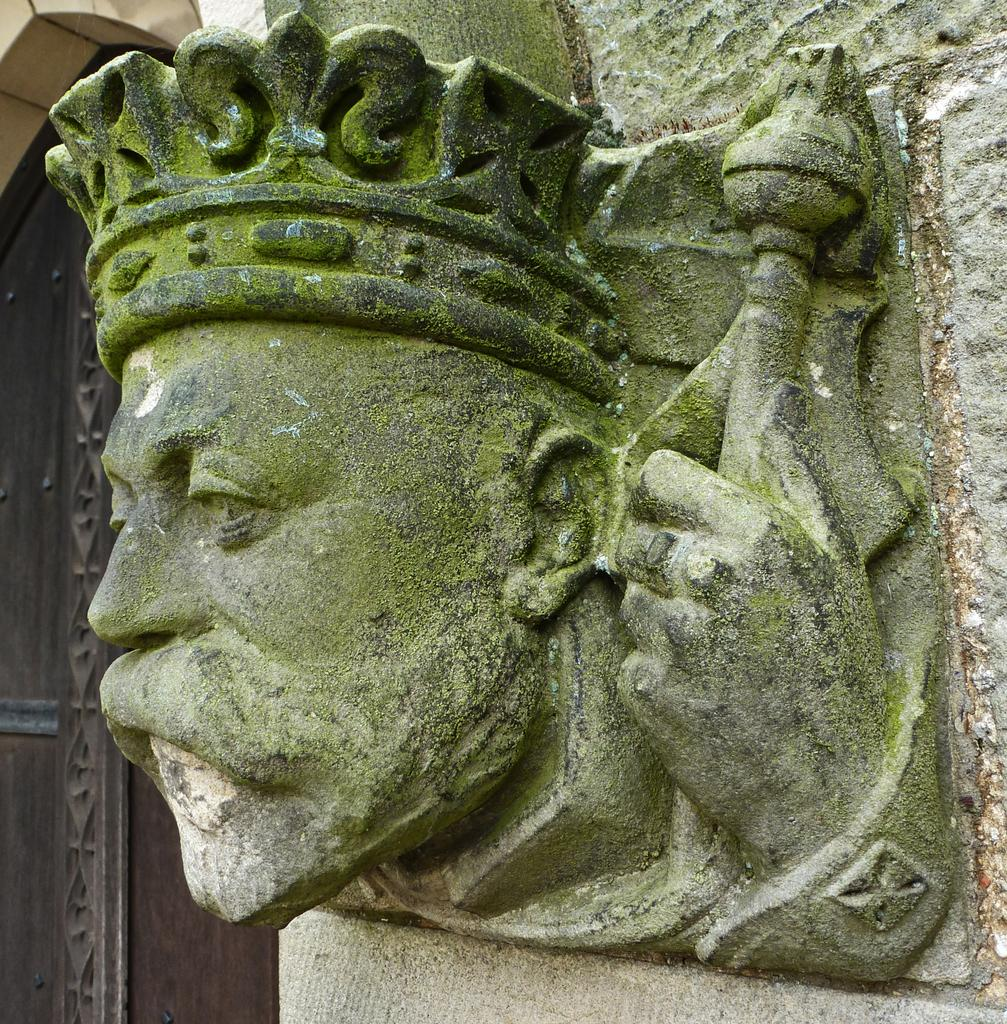What type of objects are on the wall in the image? There are statues on the wall in the image. What architectural feature is present in the image? There is a door in the image. What type of stone can be seen falling from the wall in the image? There is no stone falling from the wall in the image. What type of loss is depicted in the image? There is no depiction of loss in the image; it features statues on the wall and a door. 